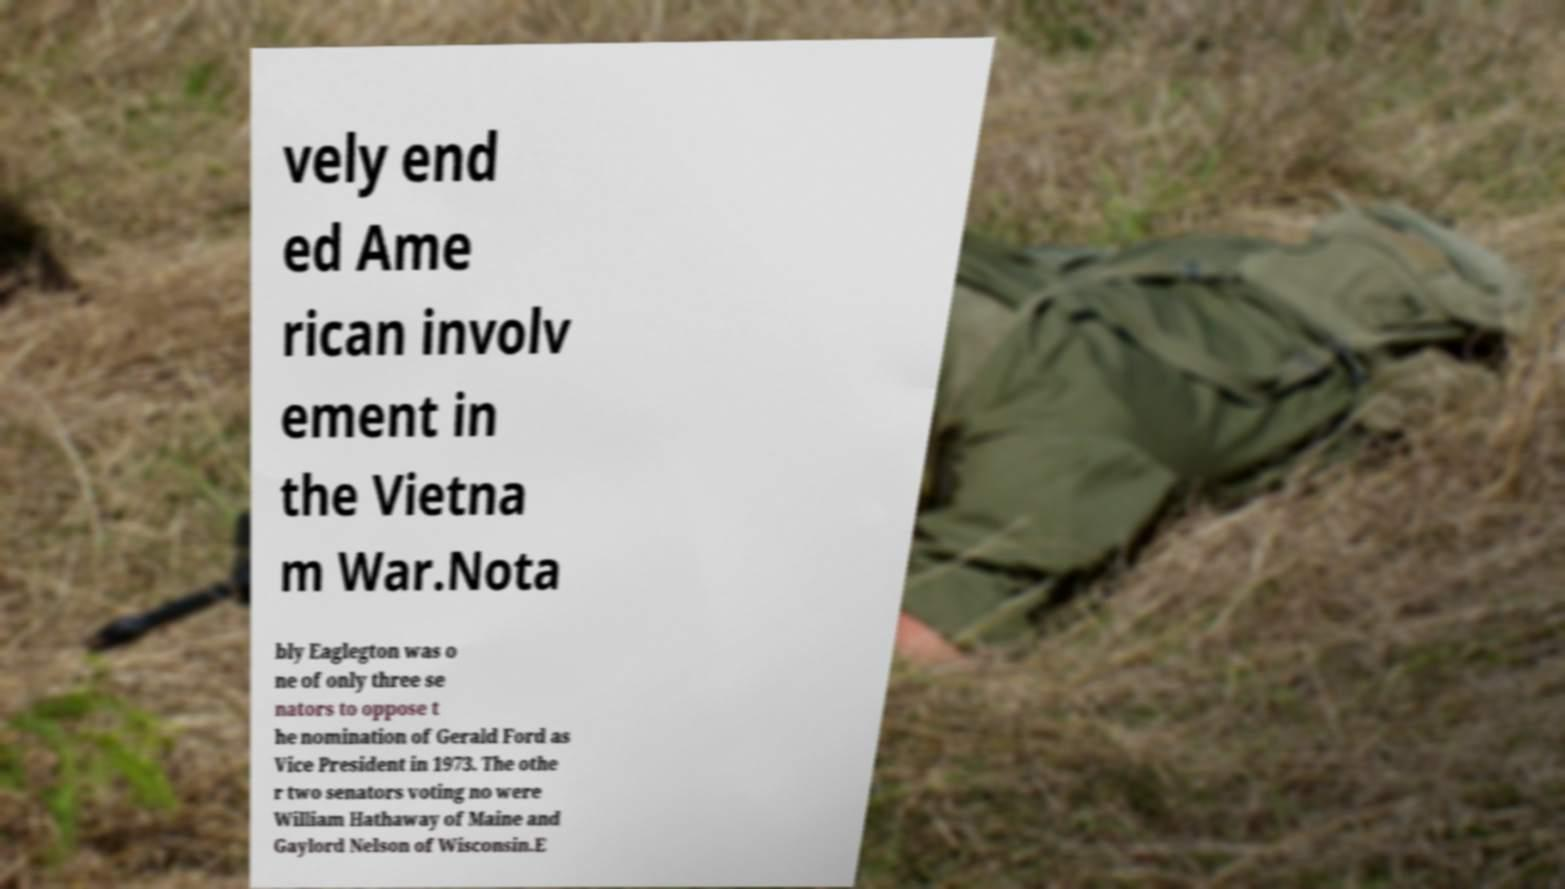Please read and relay the text visible in this image. What does it say? vely end ed Ame rican involv ement in the Vietna m War.Nota bly Eaglegton was o ne of only three se nators to oppose t he nomination of Gerald Ford as Vice President in 1973. The othe r two senators voting no were William Hathaway of Maine and Gaylord Nelson of Wisconsin.E 